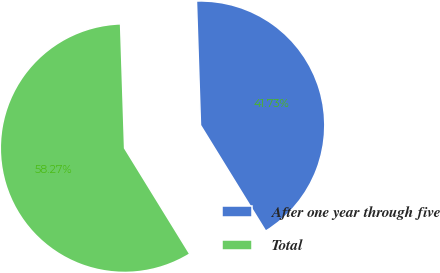Convert chart to OTSL. <chart><loc_0><loc_0><loc_500><loc_500><pie_chart><fcel>After one year through five<fcel>Total<nl><fcel>41.73%<fcel>58.27%<nl></chart> 